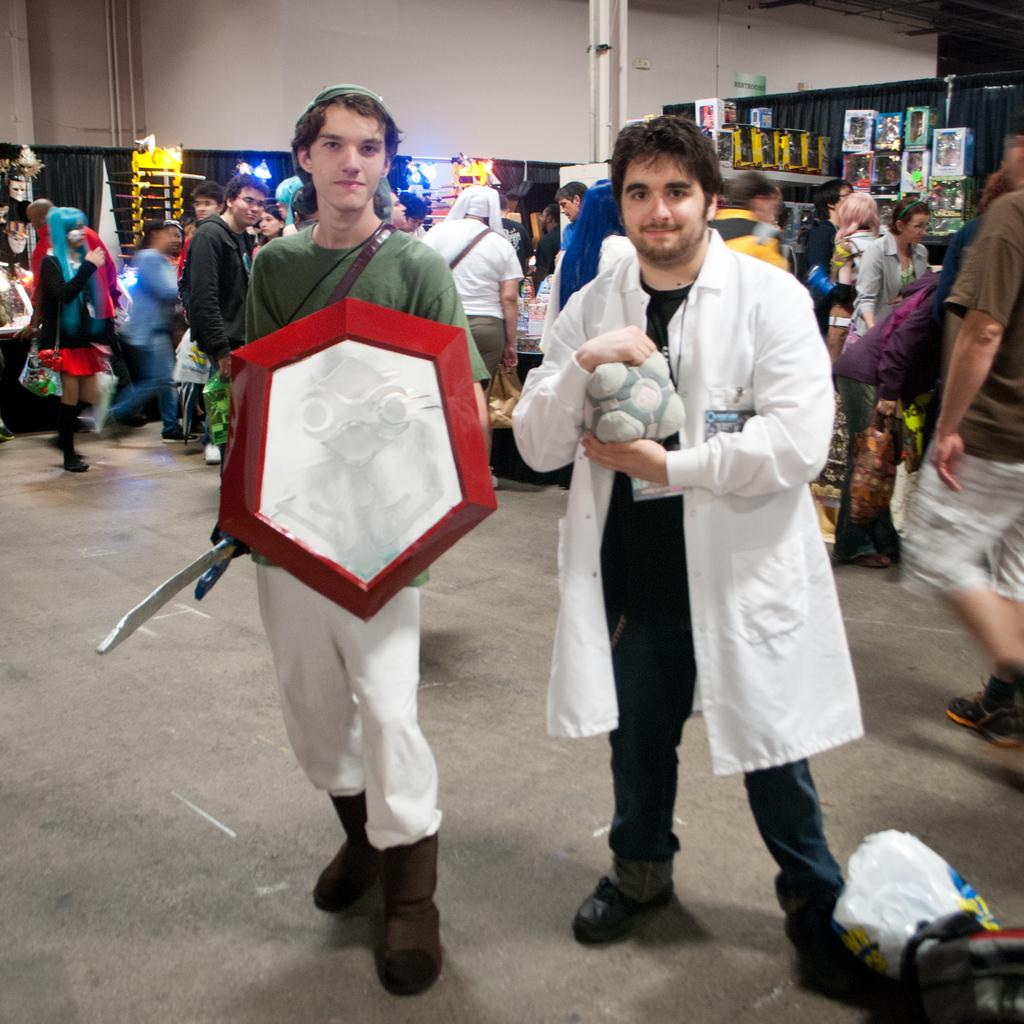How many people are visible in the image? There are two persons standing in the image. What are the two persons holding in their hands? The two persons are holding an object in their hands. Can you describe the background of the image? There are other persons and objects in the background of the image. What type of grape is being used to draw on the sidewalk in the image? There is no grape or drawing on the sidewalk present in the image. How does the crowd in the image react to the chalk drawing? There is no crowd or chalk drawing present in the image. 